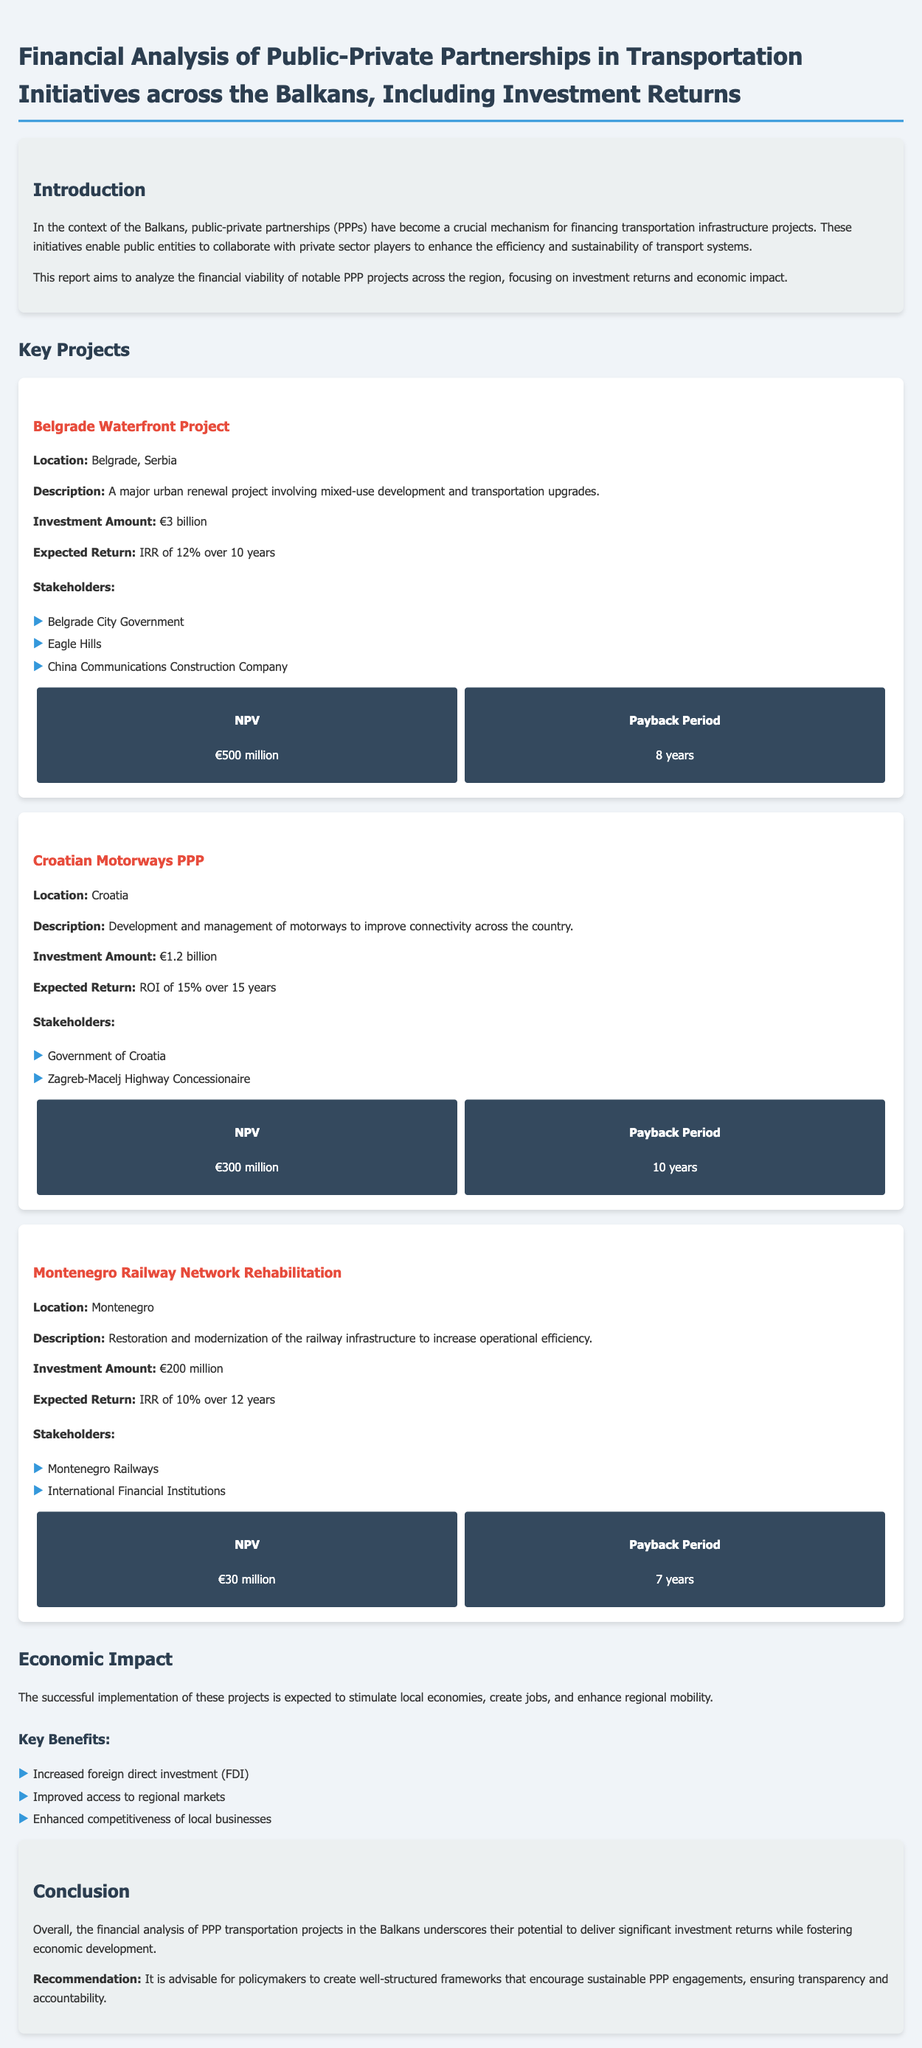What is the investment amount for the Belgrade Waterfront Project? The investment amount for the Belgrade Waterfront Project is detailed in the document as €3 billion.
Answer: €3 billion What is the expected return for the Croatian Motorways PPP? The expected return for the Croatian Motorways PPP is stated as ROI of 15% over 15 years.
Answer: ROI of 15% What is the payback period for the Montenegro Railway Network Rehabilitation? The payback period is specified in the section for the Montenegro Railway Network Rehabilitation as 7 years.
Answer: 7 years What are the three key benefits mentioned in the economic impact section? The document lists increased foreign direct investment (FDI), improved access to regional markets, and enhanced competitiveness of local businesses as the benefits.
Answer: Increased FDI, improved access to regional markets, enhanced competitiveness of local businesses How much is the Net Present Value (NPV) for the Belgrade Waterfront Project? The NPV for the Belgrade Waterfront Project is presented in the document as €500 million.
Answer: €500 million Which stakeholders are involved in the Croatian Motorways PPP? The document mentions the Government of Croatia and the Zagreb-Macelj Highway Concessionaire as stakeholders involved in the Croatian Motorways PPP.
Answer: Government of Croatia, Zagreb-Macelj Highway Concessionaire What is the total investment amount for the three projects mentioned? This can be determined by adding the investment amounts: €3 billion + €1.2 billion + €200 million, resulting in €4.4 billion total investment.
Answer: €4.4 billion What is the location of the Montenegro Railway Network Rehabilitation? The location of the Montenegro Railway Network Rehabilitation project is specified in the document as Montenegro.
Answer: Montenegro 